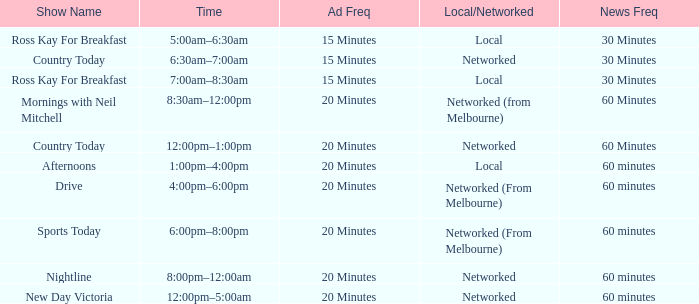What News Freq has a Time of 1:00pm–4:00pm? 60 minutes. 